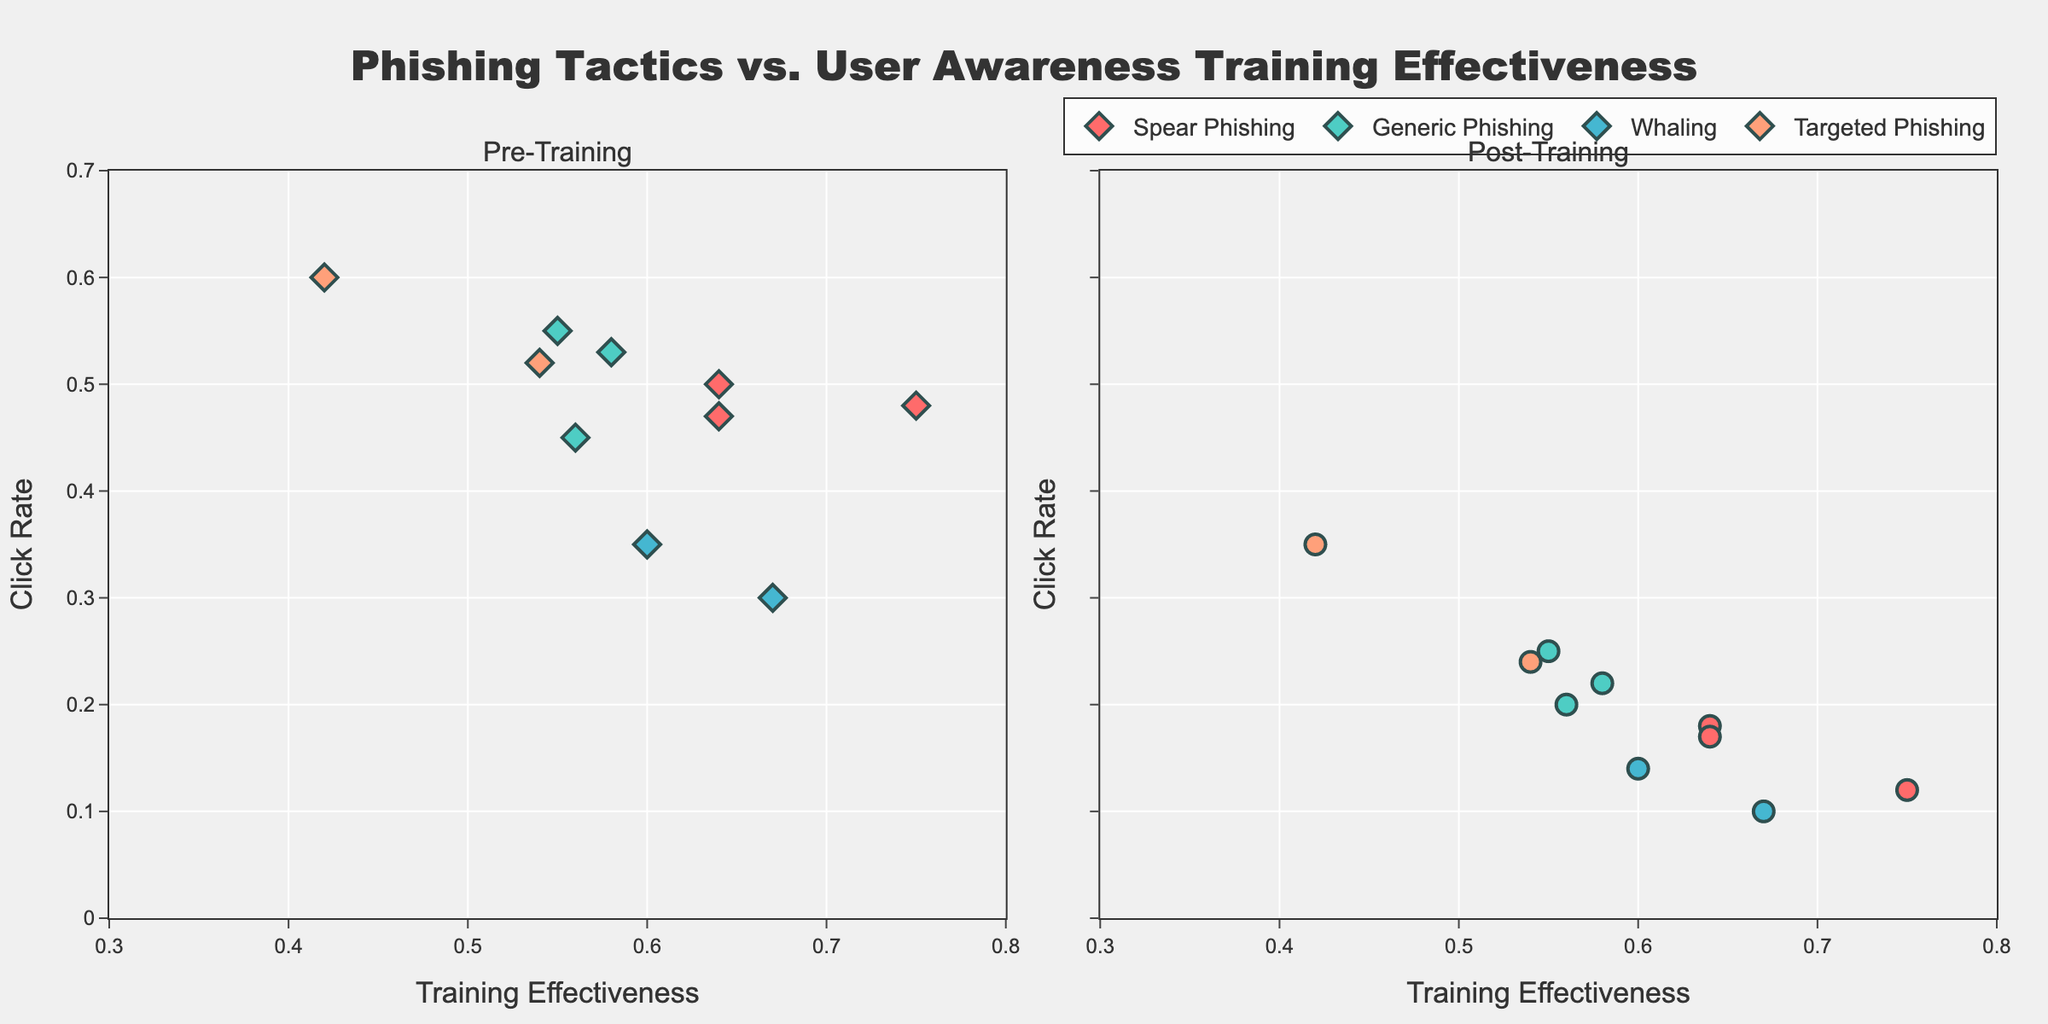What's the title of the figure? The title is displayed at the top center of the figure in a larger font size and more prominent color. It is usually written distinctively to indicate the main topic or the focus of the figure.
Answer: Phishing Tactics vs. User Awareness Training Effectiveness How does the click rate change pre-training and post-training for Spear Phishing at Acme Corp? Observing the pre-training subplot for Spear Phishing and locating the Acme Corp data point shows a higher click rate. Then, checking the post-training subplot for the same tactic shows a reduced click rate.
Answer: From 0.48 to 0.12 How many organizations are associated with Whaling tactics? Each group represented by a unique color and symbol on the scatter plot corresponds to different tactics. Counting the distinct markers for "Whaling" across both subplots will provide the answer.
Answer: 2 What is the training effectiveness range across all organizations? Training effectiveness is plotted on the x-axis of both subplots. Observing the lowest and highest values in the x-axis range will indicate the minimum and maximum effectiveness values.
Answer: 0.42 to 0.75 Which organization showed the highest reduction in click rate for Targeted Phishing? By examining both subplots, identify data points corresponding to Targeted Phishing and compare the pre- and post-training click rates. Calculate the reduction for each organization to determine the highest.
Answer: Initech Compare the post-training click rates between Generic Phishing and Whaling tactics. Which has a lower average click rate? For post-training click rates, locate the data points for Generic Phishing and Whaling in the post-training subplot. Calculate the average click rate for each tactic and compare the values.
Answer: Whaling has a lower average click rate What pattern can be observed between Training Effectiveness and the post-training Click Rate for Stark Industries? Locate the data points for Stark Industries in the post-training subplot. Compare the Training Effectiveness with the observed post-training Click Rate to determine any visible correlation.
Answer: Higher effectiveness leads to a lower click rate Of the organizations using Spear Phishing tactics, which has the lowest post-training click rate? Reviewing the post-training subplot for data points corresponding to Spear Phishing tactics, identify the lowest value along the y-axis.
Answer: Acme Corp What is the average post-training click rate for organizations employing Generic Phishing? Locate all data points for Generic Phishing in the post-training subplot. Sum their post-training click rates and divide by the number of organizations to determine the average.
Answer: (0.25 + 0.20 + 0.22) / 3 = 0.22 